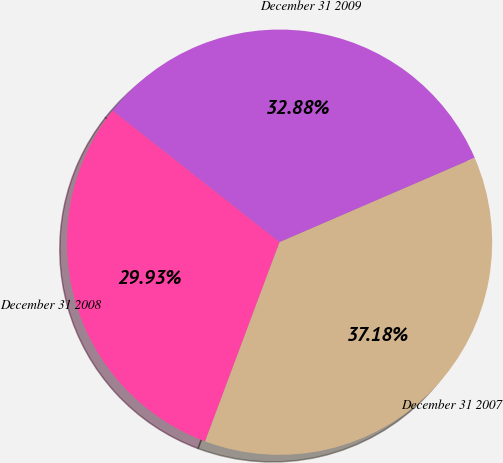Convert chart. <chart><loc_0><loc_0><loc_500><loc_500><pie_chart><fcel>December 31 2009<fcel>December 31 2008<fcel>December 31 2007<nl><fcel>32.88%<fcel>29.93%<fcel>37.18%<nl></chart> 